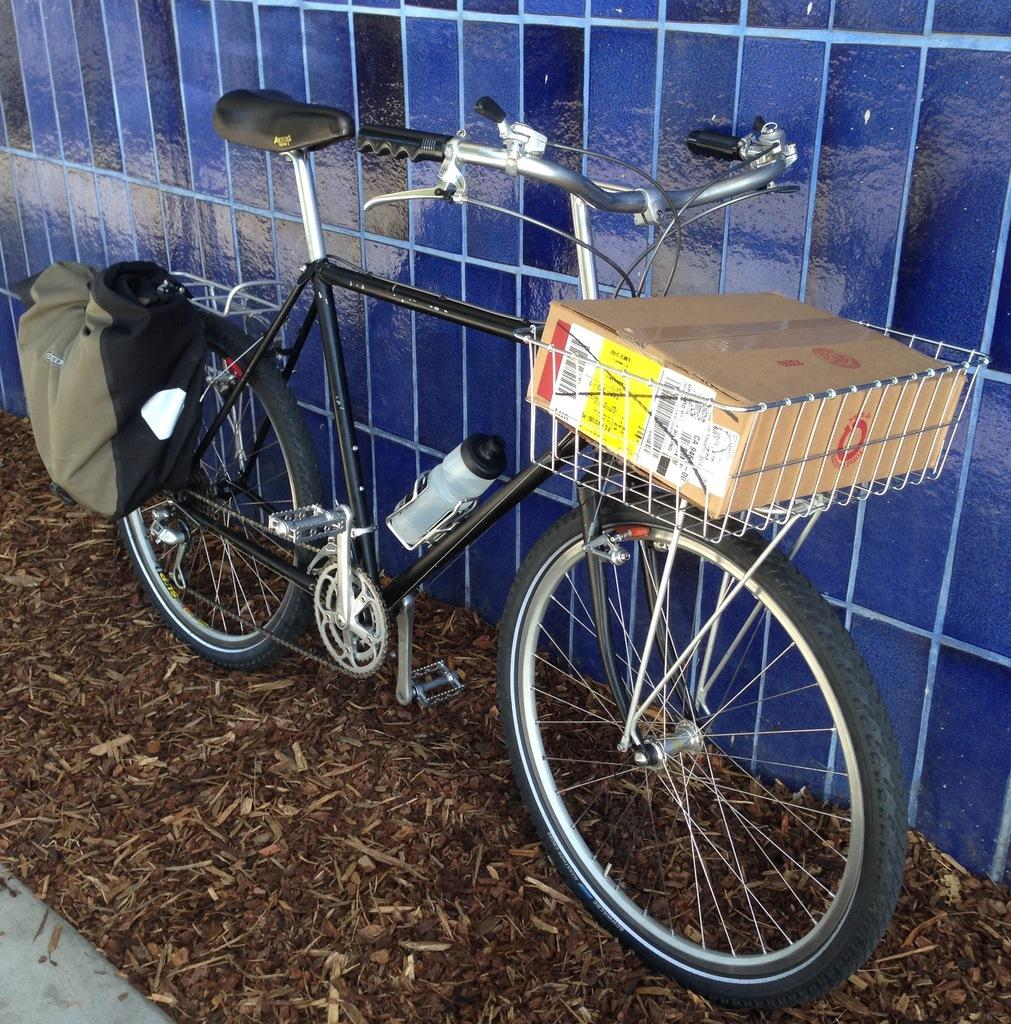What object is placed on the floor in the image? There is a bicycle on the floor in the image. What type of container is present in the image? There is a cardboard carton in the image. What type of bottle can be seen in the image? There is a disposal bottle in the image. What type of bag is visible in the image? There is a bag in the image. What material is visible in the foreground of the image? Saw dust and twigs are present in the foreground of the image. How many cherries are on the bicycle in the image? There are no cherries present in the image. What type of mice can be seen interacting with the cardboard carton in the image? There are no mice present in the image. 